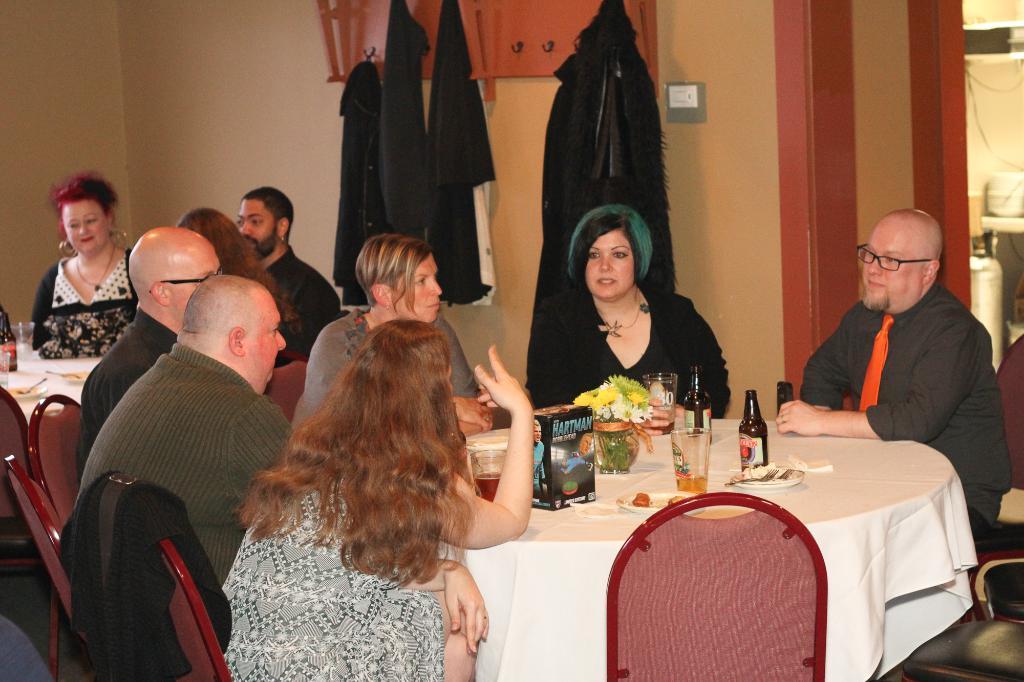Please provide a concise description of this image. In this image I can see a group of people who are sitting on a chair in front of a table. On the table we have a box and other objects on it. 